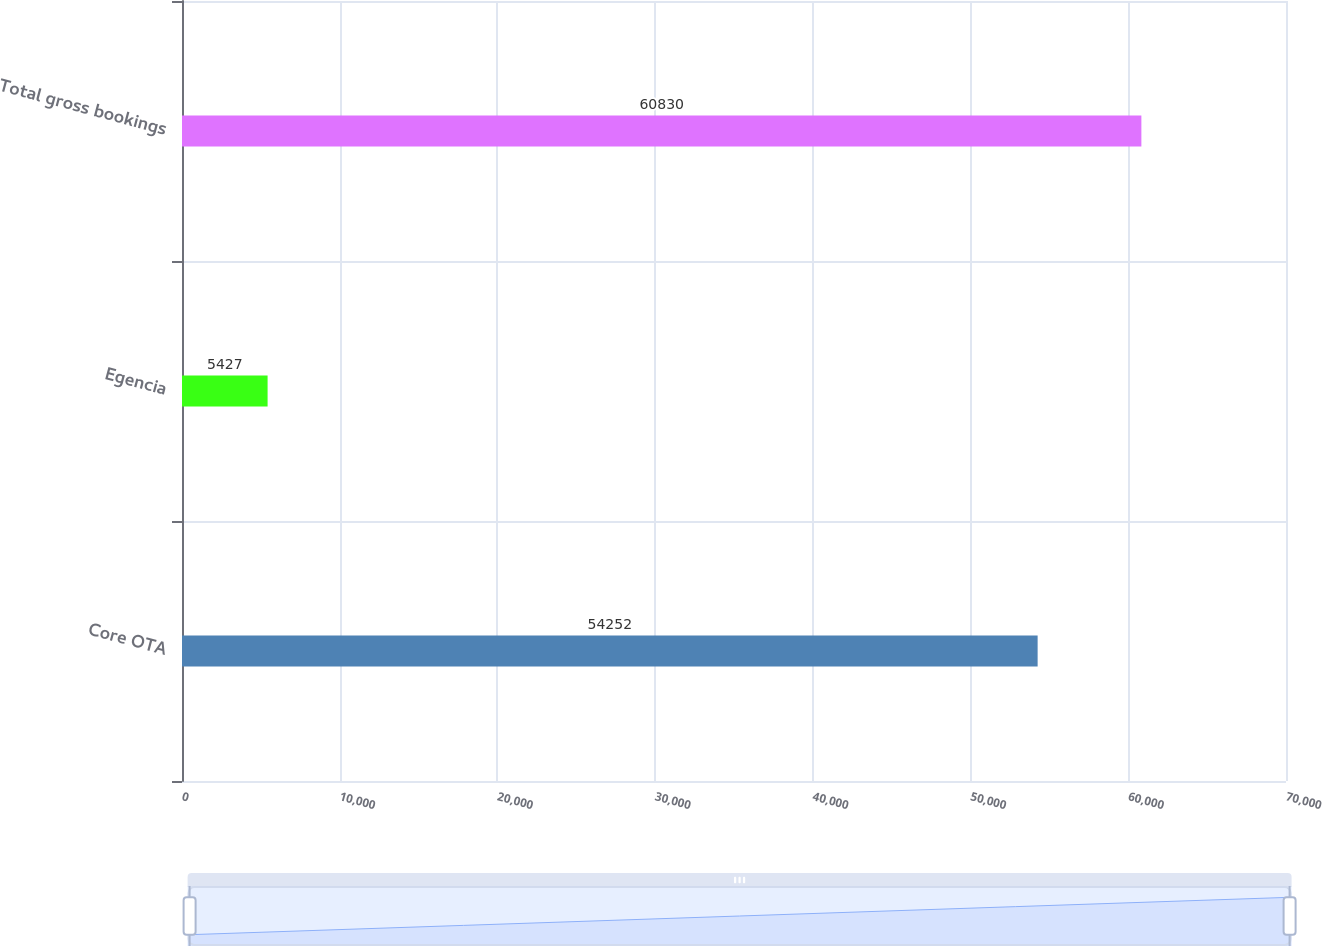<chart> <loc_0><loc_0><loc_500><loc_500><bar_chart><fcel>Core OTA<fcel>Egencia<fcel>Total gross bookings<nl><fcel>54252<fcel>5427<fcel>60830<nl></chart> 